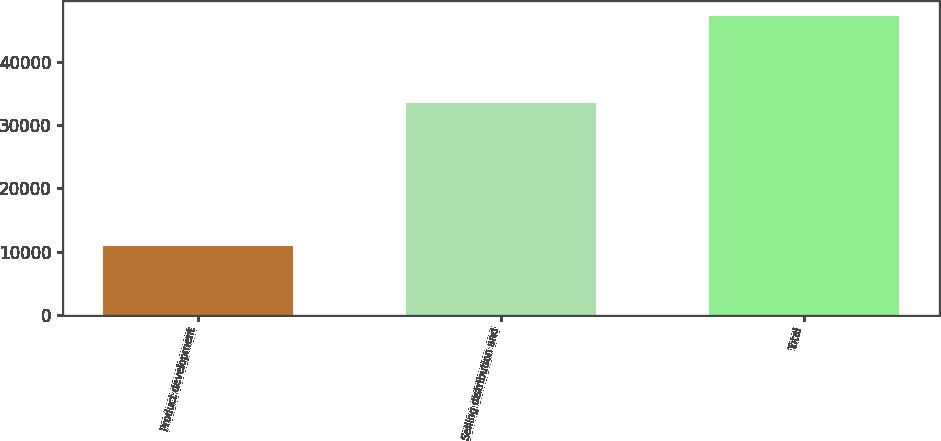Convert chart to OTSL. <chart><loc_0><loc_0><loc_500><loc_500><bar_chart><fcel>Product development<fcel>Selling distribution and<fcel>Total<nl><fcel>10949<fcel>33463<fcel>47176<nl></chart> 